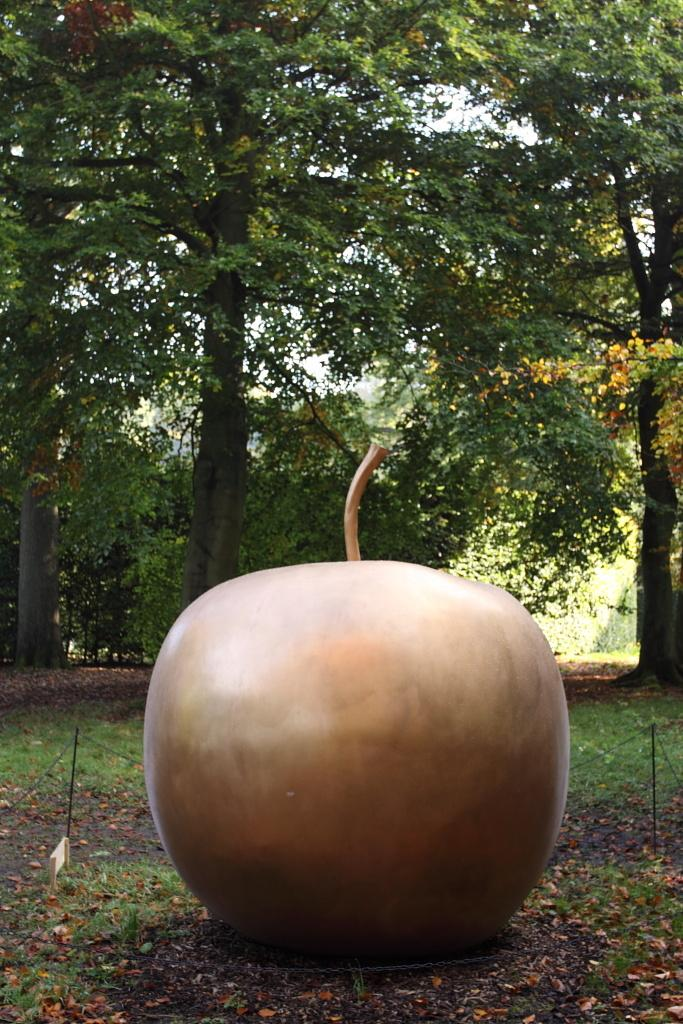What is the color of the object in the image? The object in the image is brown in color. What can be seen in the background of the image? There are trees and the sky visible in the background of the image. What is the color of the trees in the image? The trees in the image are green in color. What is the color of the sky in the image? The sky in the image is white in color. How many eyes can be seen on the object in the image? There are no eyes visible on the object in the image, as it is not a living being. 